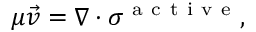Convert formula to latex. <formula><loc_0><loc_0><loc_500><loc_500>\mu \vec { v } = \nabla \cdot \sigma ^ { a c t i v e } ,</formula> 